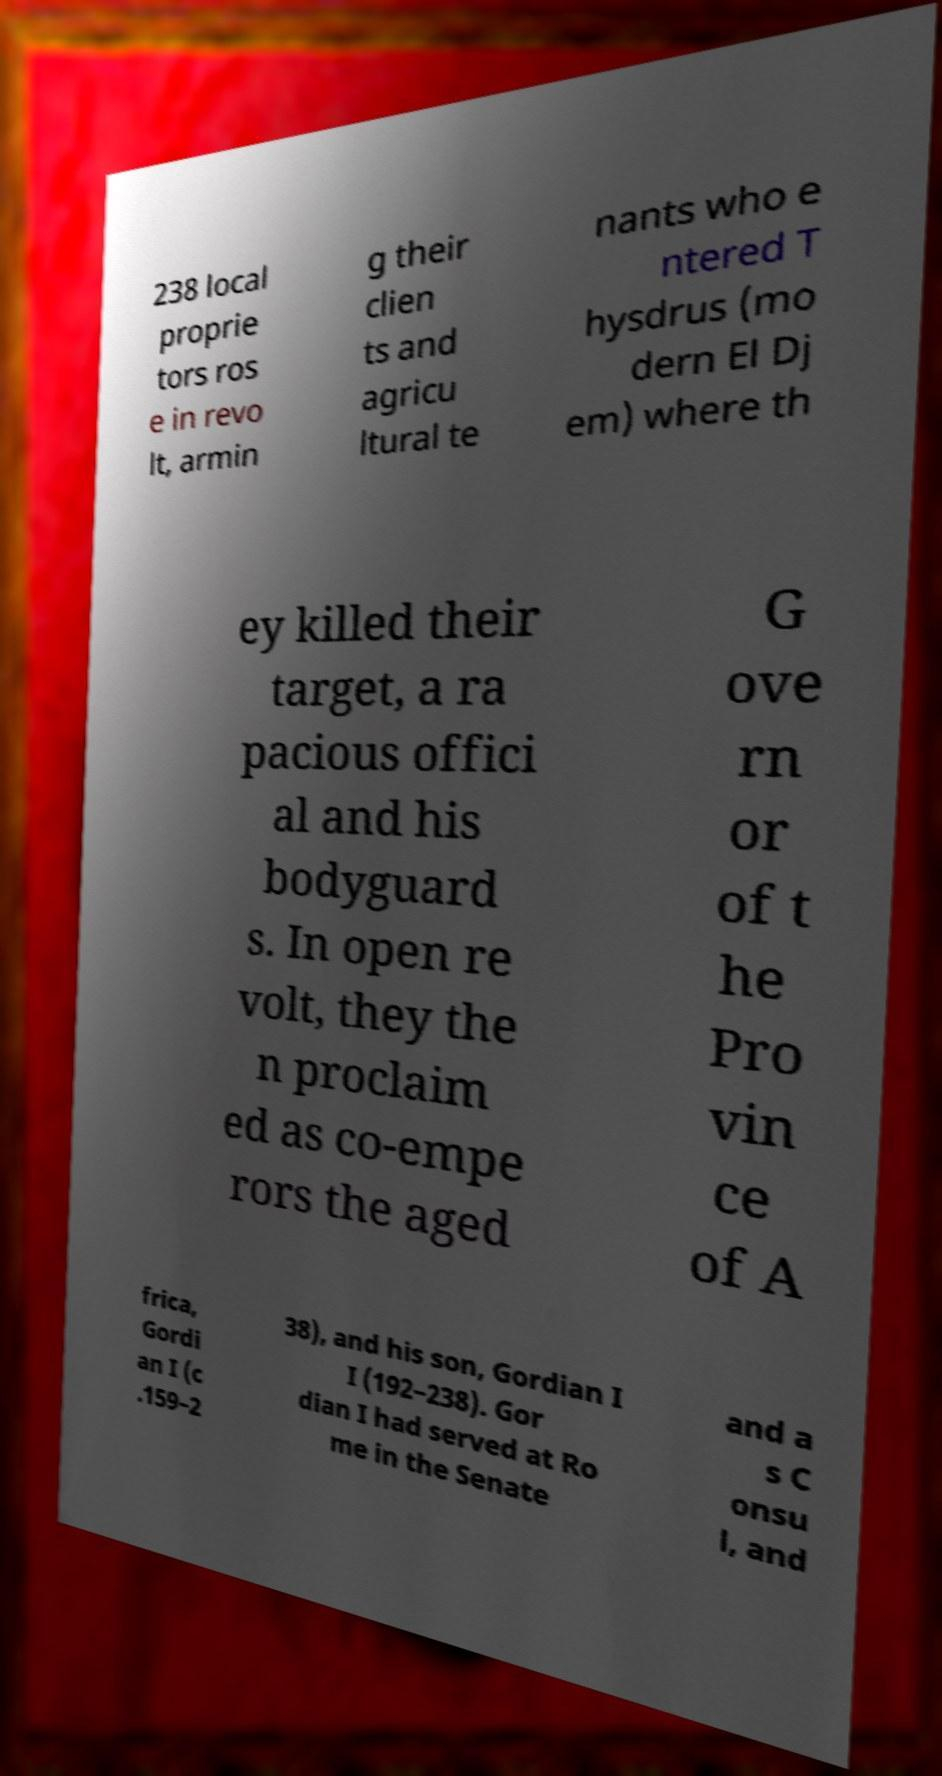Can you read and provide the text displayed in the image?This photo seems to have some interesting text. Can you extract and type it out for me? 238 local proprie tors ros e in revo lt, armin g their clien ts and agricu ltural te nants who e ntered T hysdrus (mo dern El Dj em) where th ey killed their target, a ra pacious offici al and his bodyguard s. In open re volt, they the n proclaim ed as co-empe rors the aged G ove rn or of t he Pro vin ce of A frica, Gordi an I (c .159–2 38), and his son, Gordian I I (192–238). Gor dian I had served at Ro me in the Senate and a s C onsu l, and 